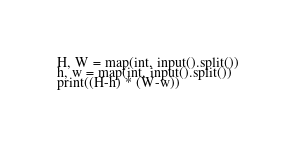Convert code to text. <code><loc_0><loc_0><loc_500><loc_500><_Python_>H, W = map(int, input().split())
h, w = map(int, input().split())
print((H-h) * (W-w))</code> 